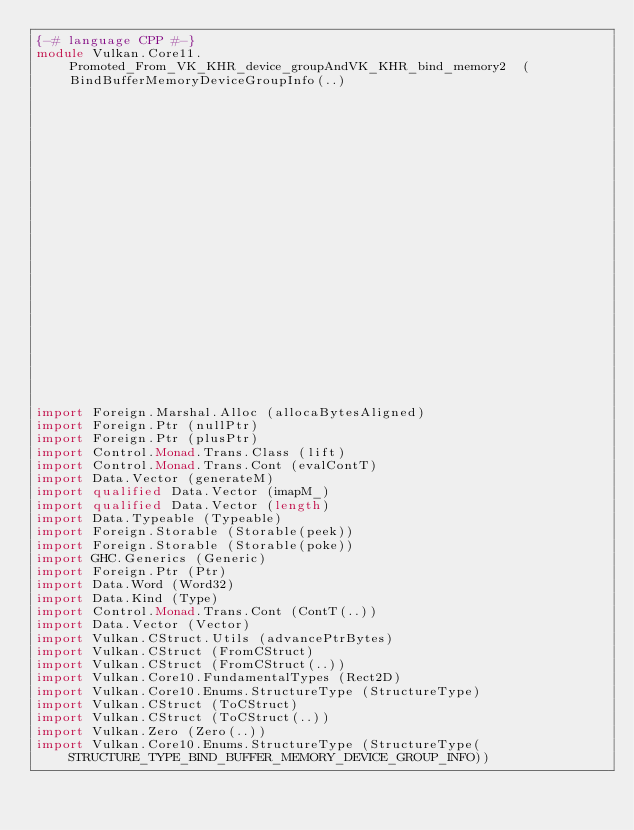Convert code to text. <code><loc_0><loc_0><loc_500><loc_500><_Haskell_>{-# language CPP #-}
module Vulkan.Core11.Promoted_From_VK_KHR_device_groupAndVK_KHR_bind_memory2  ( BindBufferMemoryDeviceGroupInfo(..)
                                                                              , BindImageMemoryDeviceGroupInfo(..)
                                                                              , StructureType(..)
                                                                              , ImageCreateFlagBits(..)
                                                                              , ImageCreateFlags
                                                                              ) where

import Foreign.Marshal.Alloc (allocaBytesAligned)
import Foreign.Ptr (nullPtr)
import Foreign.Ptr (plusPtr)
import Control.Monad.Trans.Class (lift)
import Control.Monad.Trans.Cont (evalContT)
import Data.Vector (generateM)
import qualified Data.Vector (imapM_)
import qualified Data.Vector (length)
import Data.Typeable (Typeable)
import Foreign.Storable (Storable(peek))
import Foreign.Storable (Storable(poke))
import GHC.Generics (Generic)
import Foreign.Ptr (Ptr)
import Data.Word (Word32)
import Data.Kind (Type)
import Control.Monad.Trans.Cont (ContT(..))
import Data.Vector (Vector)
import Vulkan.CStruct.Utils (advancePtrBytes)
import Vulkan.CStruct (FromCStruct)
import Vulkan.CStruct (FromCStruct(..))
import Vulkan.Core10.FundamentalTypes (Rect2D)
import Vulkan.Core10.Enums.StructureType (StructureType)
import Vulkan.CStruct (ToCStruct)
import Vulkan.CStruct (ToCStruct(..))
import Vulkan.Zero (Zero(..))
import Vulkan.Core10.Enums.StructureType (StructureType(STRUCTURE_TYPE_BIND_BUFFER_MEMORY_DEVICE_GROUP_INFO))</code> 